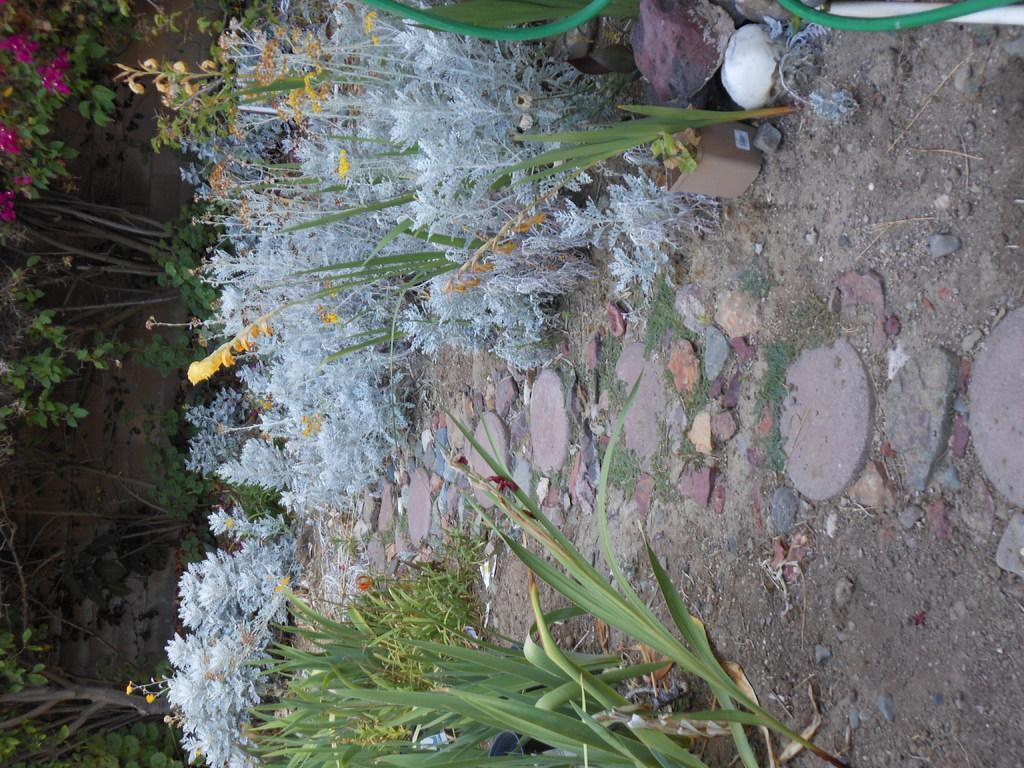Please provide a concise description of this image. In the image we can see there are plants on the ground and there are lot of trees at the back. There are flowers on the plants. 